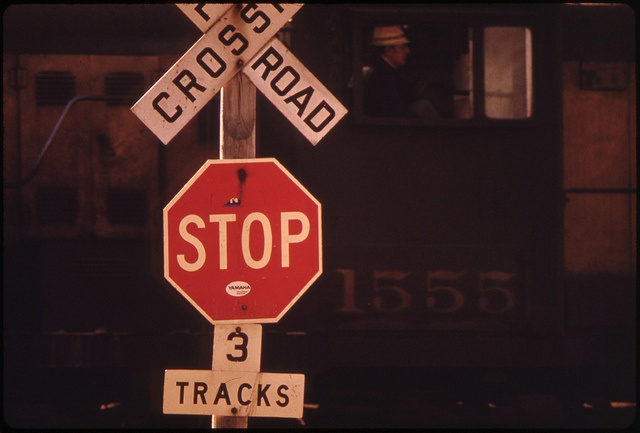Describe the objects in this image and their specific colors. I can see train in black, maroon, and brown tones, people in black, maroon, salmon, and tan tones, and stop sign in black, brown, tan, and salmon tones in this image. 